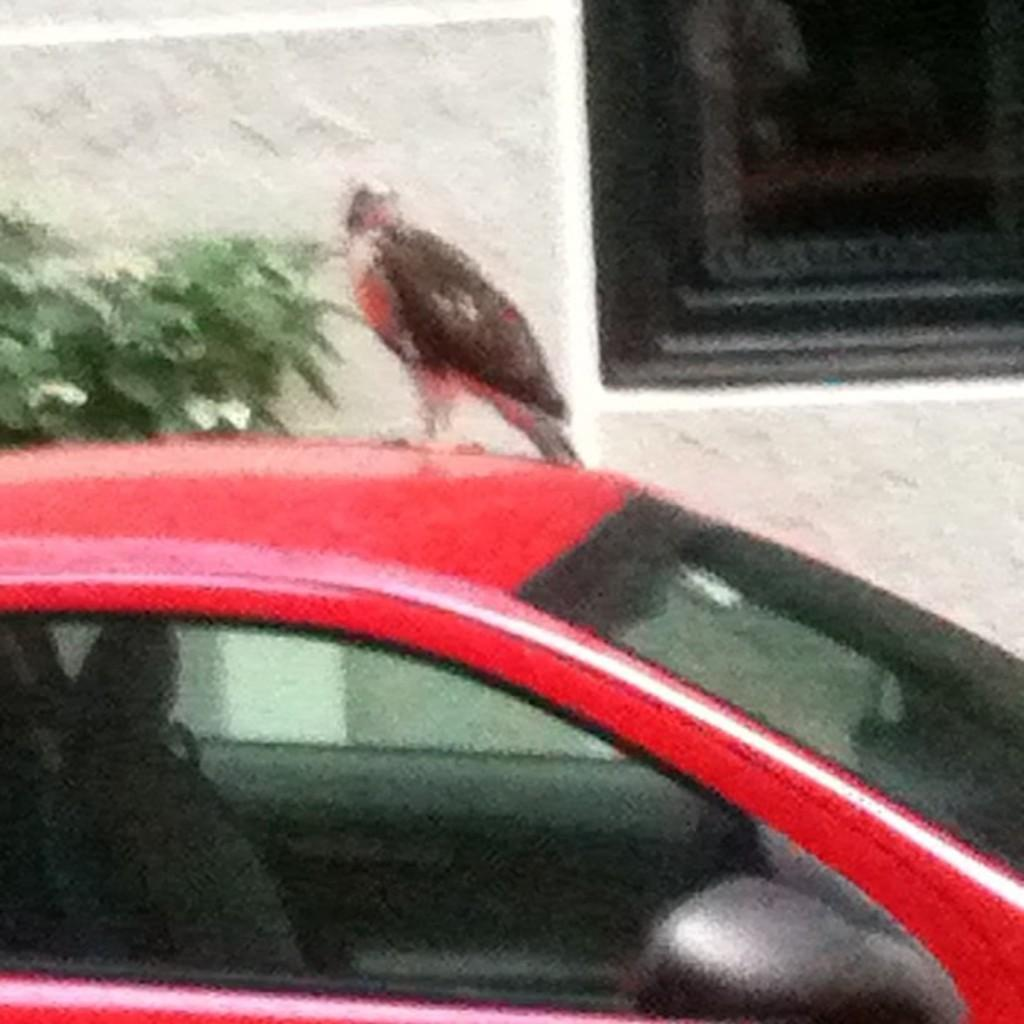What is on top of the car in the image? There is a bird on a red color car in the image. What can be seen behind the car? There is a plant behind the car. What is visible in the background of the image? There is a window in the background, and behind the window, there is a wall. Can you tell me how many light bulbs are hanging from the wall in the image? There are no light bulbs visible in the image; the wall is behind the window. What type of ocean can be seen in the background of the image? There is no ocean present in the image; it features a car with a bird, a plant, a window, and a wall. 